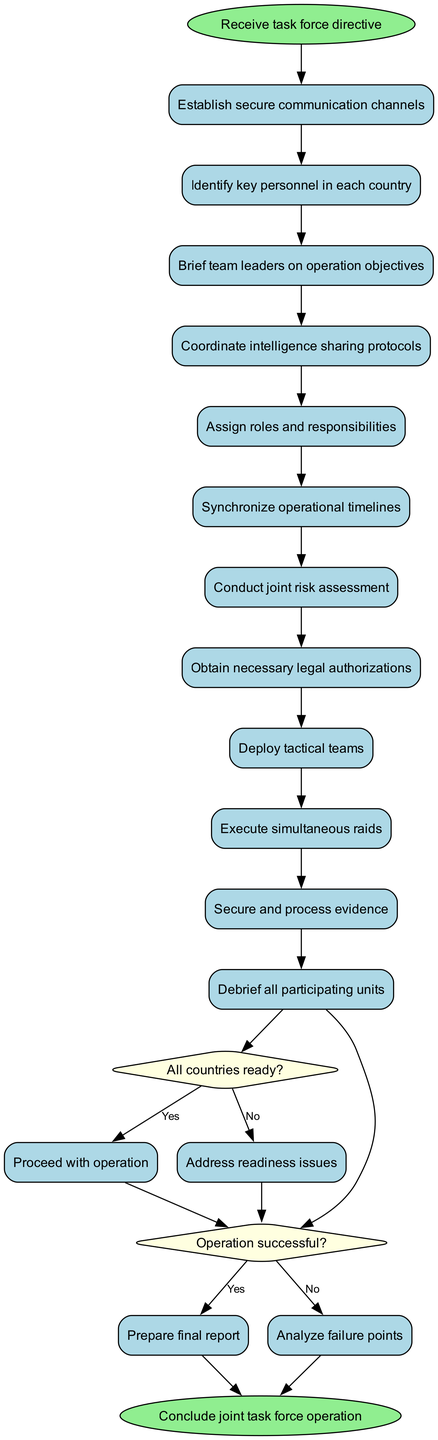What is the first activity in the diagram? The first activity listed after the start node, which is connected directly to it, is "Establish secure communication channels." This is derived from the structured sequence of activities in the diagram.
Answer: Establish secure communication channels How many activities are included in the operation? The total number of activities can be counted directly from the list in the diagram. There are 12 distinct activities from "Establish secure communication channels" to "Debrief all participating units."
Answer: 12 What decision follows the last activity? After the last activity "Secure and process evidence," the decision node that follows is "Operation successful?" This is explicitly shown as the flow directs to a decision point.
Answer: Operation successful? What is the outcome if all countries are not ready? If the answer to the question "All countries ready?" is "No," the next step indicated in the diagram is to "Address readiness issues." This outcome illustrates the corrective action needed before proceeding.
Answer: Address readiness issues How many decisions are made in the diagram? The diagram includes two decision nodes: one for "All countries ready?" and another for "Operation successful?" These can be directly counted from the decision section of the diagram.
Answer: 2 What are the roles assigned after the decision on operation readiness? Immediately after the decision node "All countries ready?" and if the answer is "Yes," the flow directs to the next activity, which is "Assign roles and responsibilities." This indicates the subsequent steps if readiness is confirmed.
Answer: Assign roles and responsibilities What happens if the operation is analyzed for failure points? If the answer to "Operation successful?" is "No," the process flows to "Analyze failure points." This is a corrective measure taken after an unsuccessful operation, reflecting strategic evaluation.
Answer: Analyze failure points What is the final step in the operation? The end of the process culminates with the node "Conclude joint task force operation," which signifies the completion of all activities and decisions taken during the operation.
Answer: Conclude joint task force operation 